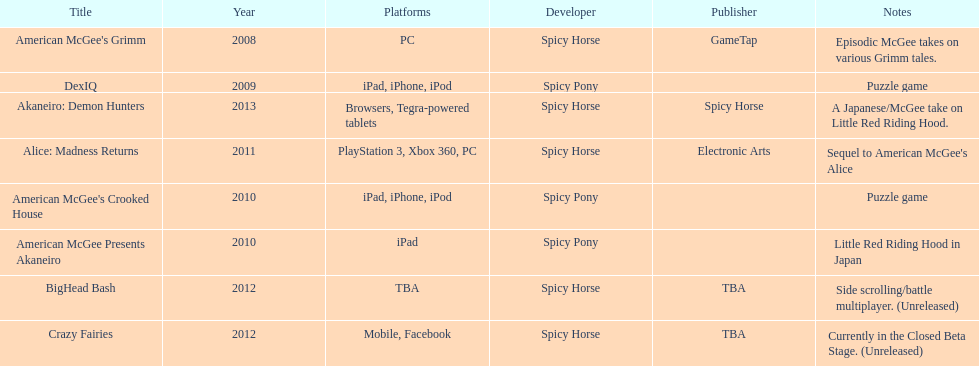What is the total number of games developed by spicy horse? 5. 